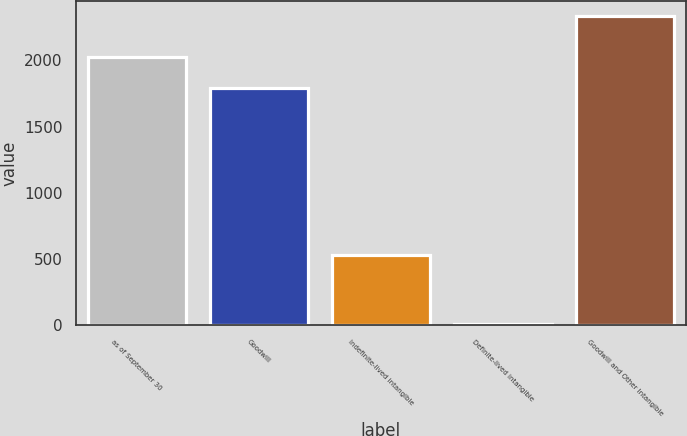<chart> <loc_0><loc_0><loc_500><loc_500><bar_chart><fcel>as of September 30<fcel>Goodwill<fcel>Indefinite-lived intangible<fcel>Definite-lived intangible<fcel>Goodwill and Other Intangible<nl><fcel>2027.35<fcel>1794.8<fcel>530.7<fcel>7.9<fcel>2333.4<nl></chart> 